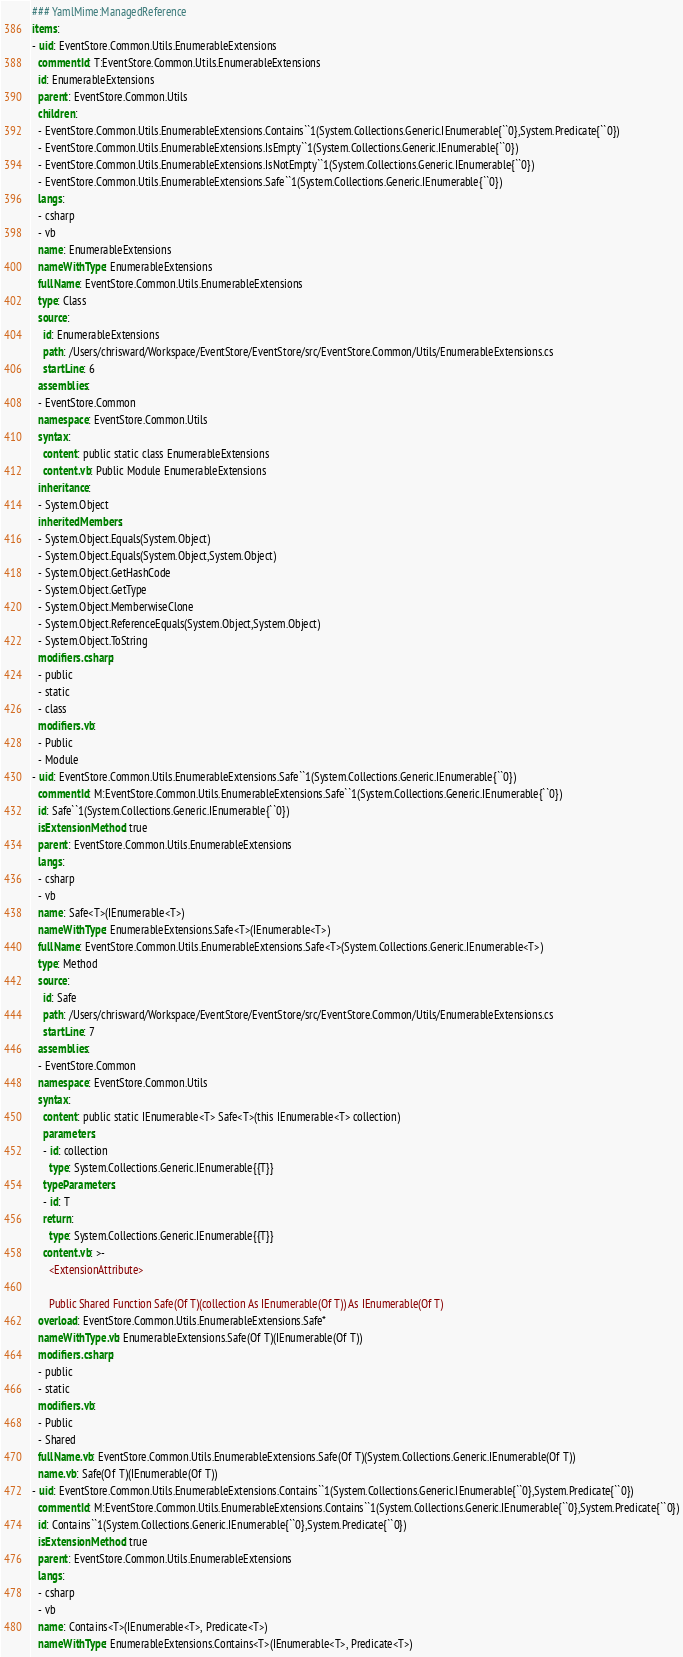Convert code to text. <code><loc_0><loc_0><loc_500><loc_500><_YAML_>### YamlMime:ManagedReference
items:
- uid: EventStore.Common.Utils.EnumerableExtensions
  commentId: T:EventStore.Common.Utils.EnumerableExtensions
  id: EnumerableExtensions
  parent: EventStore.Common.Utils
  children:
  - EventStore.Common.Utils.EnumerableExtensions.Contains``1(System.Collections.Generic.IEnumerable{``0},System.Predicate{``0})
  - EventStore.Common.Utils.EnumerableExtensions.IsEmpty``1(System.Collections.Generic.IEnumerable{``0})
  - EventStore.Common.Utils.EnumerableExtensions.IsNotEmpty``1(System.Collections.Generic.IEnumerable{``0})
  - EventStore.Common.Utils.EnumerableExtensions.Safe``1(System.Collections.Generic.IEnumerable{``0})
  langs:
  - csharp
  - vb
  name: EnumerableExtensions
  nameWithType: EnumerableExtensions
  fullName: EventStore.Common.Utils.EnumerableExtensions
  type: Class
  source:
    id: EnumerableExtensions
    path: /Users/chrisward/Workspace/EventStore/EventStore/src/EventStore.Common/Utils/EnumerableExtensions.cs
    startLine: 6
  assemblies:
  - EventStore.Common
  namespace: EventStore.Common.Utils
  syntax:
    content: public static class EnumerableExtensions
    content.vb: Public Module EnumerableExtensions
  inheritance:
  - System.Object
  inheritedMembers:
  - System.Object.Equals(System.Object)
  - System.Object.Equals(System.Object,System.Object)
  - System.Object.GetHashCode
  - System.Object.GetType
  - System.Object.MemberwiseClone
  - System.Object.ReferenceEquals(System.Object,System.Object)
  - System.Object.ToString
  modifiers.csharp:
  - public
  - static
  - class
  modifiers.vb:
  - Public
  - Module
- uid: EventStore.Common.Utils.EnumerableExtensions.Safe``1(System.Collections.Generic.IEnumerable{``0})
  commentId: M:EventStore.Common.Utils.EnumerableExtensions.Safe``1(System.Collections.Generic.IEnumerable{``0})
  id: Safe``1(System.Collections.Generic.IEnumerable{``0})
  isExtensionMethod: true
  parent: EventStore.Common.Utils.EnumerableExtensions
  langs:
  - csharp
  - vb
  name: Safe<T>(IEnumerable<T>)
  nameWithType: EnumerableExtensions.Safe<T>(IEnumerable<T>)
  fullName: EventStore.Common.Utils.EnumerableExtensions.Safe<T>(System.Collections.Generic.IEnumerable<T>)
  type: Method
  source:
    id: Safe
    path: /Users/chrisward/Workspace/EventStore/EventStore/src/EventStore.Common/Utils/EnumerableExtensions.cs
    startLine: 7
  assemblies:
  - EventStore.Common
  namespace: EventStore.Common.Utils
  syntax:
    content: public static IEnumerable<T> Safe<T>(this IEnumerable<T> collection)
    parameters:
    - id: collection
      type: System.Collections.Generic.IEnumerable{{T}}
    typeParameters:
    - id: T
    return:
      type: System.Collections.Generic.IEnumerable{{T}}
    content.vb: >-
      <ExtensionAttribute>

      Public Shared Function Safe(Of T)(collection As IEnumerable(Of T)) As IEnumerable(Of T)
  overload: EventStore.Common.Utils.EnumerableExtensions.Safe*
  nameWithType.vb: EnumerableExtensions.Safe(Of T)(IEnumerable(Of T))
  modifiers.csharp:
  - public
  - static
  modifiers.vb:
  - Public
  - Shared
  fullName.vb: EventStore.Common.Utils.EnumerableExtensions.Safe(Of T)(System.Collections.Generic.IEnumerable(Of T))
  name.vb: Safe(Of T)(IEnumerable(Of T))
- uid: EventStore.Common.Utils.EnumerableExtensions.Contains``1(System.Collections.Generic.IEnumerable{``0},System.Predicate{``0})
  commentId: M:EventStore.Common.Utils.EnumerableExtensions.Contains``1(System.Collections.Generic.IEnumerable{``0},System.Predicate{``0})
  id: Contains``1(System.Collections.Generic.IEnumerable{``0},System.Predicate{``0})
  isExtensionMethod: true
  parent: EventStore.Common.Utils.EnumerableExtensions
  langs:
  - csharp
  - vb
  name: Contains<T>(IEnumerable<T>, Predicate<T>)
  nameWithType: EnumerableExtensions.Contains<T>(IEnumerable<T>, Predicate<T>)</code> 